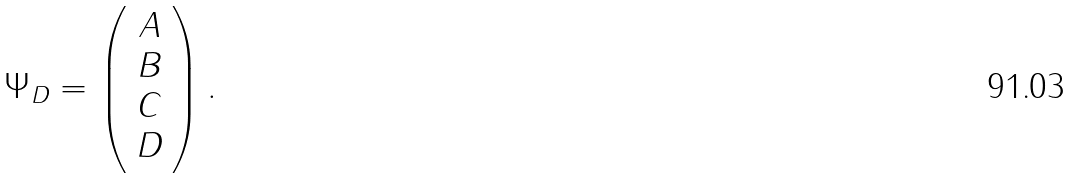<formula> <loc_0><loc_0><loc_500><loc_500>\Psi _ { D } = \left ( \begin{array} { c } { A } \\ { B } \\ { C } \\ { D } \end{array} \right ) .</formula> 